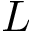<formula> <loc_0><loc_0><loc_500><loc_500>L</formula> 